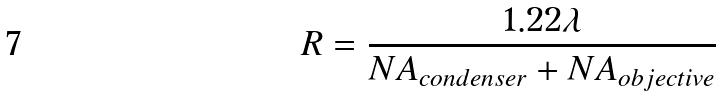Convert formula to latex. <formula><loc_0><loc_0><loc_500><loc_500>R = { \frac { 1 . 2 2 \lambda } { N A _ { c o n d e n s e r } + N A _ { o b j e c t i v e } } }</formula> 